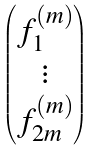Convert formula to latex. <formula><loc_0><loc_0><loc_500><loc_500>\begin{pmatrix} { f } ^ { ( m ) } _ { 1 } \\ \vdots \\ f ^ { ( m ) } _ { 2 m } \end{pmatrix}</formula> 